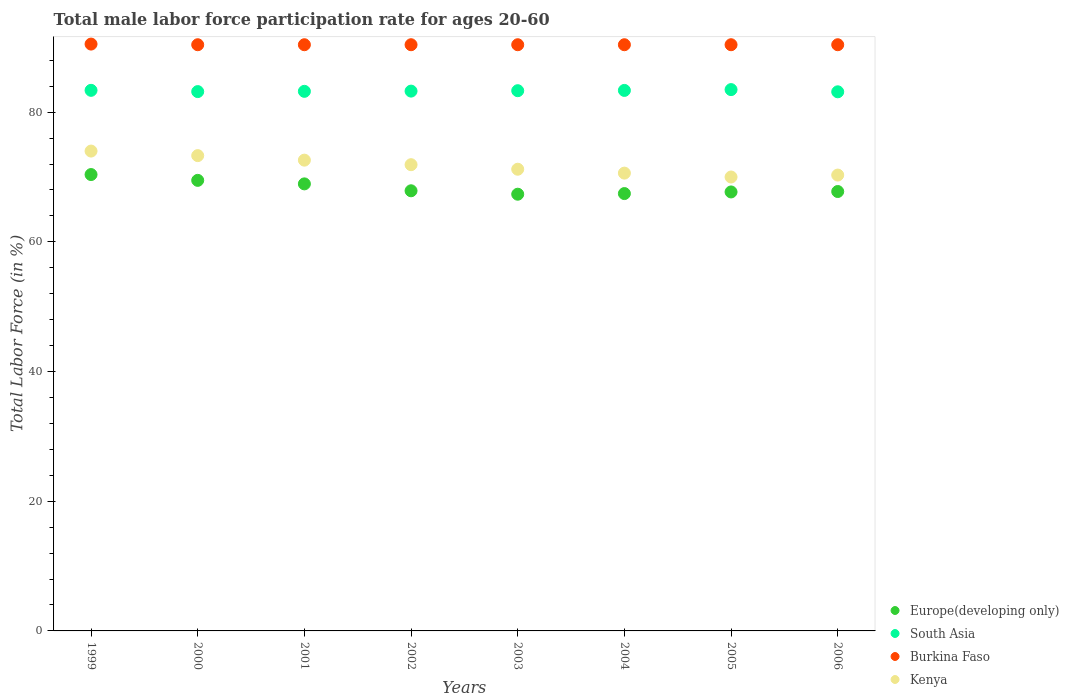What is the male labor force participation rate in Burkina Faso in 1999?
Keep it short and to the point. 90.5. Across all years, what is the maximum male labor force participation rate in South Asia?
Give a very brief answer. 83.48. Across all years, what is the minimum male labor force participation rate in South Asia?
Offer a very short reply. 83.14. In which year was the male labor force participation rate in Europe(developing only) maximum?
Make the answer very short. 1999. What is the total male labor force participation rate in Burkina Faso in the graph?
Provide a short and direct response. 723.3. What is the difference between the male labor force participation rate in Burkina Faso in 2000 and that in 2003?
Your answer should be compact. 0. What is the difference between the male labor force participation rate in Burkina Faso in 2000 and the male labor force participation rate in South Asia in 2005?
Give a very brief answer. 6.92. What is the average male labor force participation rate in South Asia per year?
Provide a succinct answer. 83.29. In the year 2002, what is the difference between the male labor force participation rate in Europe(developing only) and male labor force participation rate in Kenya?
Offer a terse response. -4.02. What is the difference between the highest and the second highest male labor force participation rate in Burkina Faso?
Your answer should be very brief. 0.1. What is the difference between the highest and the lowest male labor force participation rate in Kenya?
Make the answer very short. 4. In how many years, is the male labor force participation rate in Europe(developing only) greater than the average male labor force participation rate in Europe(developing only) taken over all years?
Give a very brief answer. 3. Is it the case that in every year, the sum of the male labor force participation rate in South Asia and male labor force participation rate in Kenya  is greater than the sum of male labor force participation rate in Europe(developing only) and male labor force participation rate in Burkina Faso?
Keep it short and to the point. Yes. Is the male labor force participation rate in Europe(developing only) strictly greater than the male labor force participation rate in Burkina Faso over the years?
Provide a short and direct response. No. How many dotlines are there?
Provide a short and direct response. 4. How many years are there in the graph?
Provide a short and direct response. 8. Are the values on the major ticks of Y-axis written in scientific E-notation?
Provide a succinct answer. No. Does the graph contain any zero values?
Keep it short and to the point. No. Does the graph contain grids?
Give a very brief answer. No. Where does the legend appear in the graph?
Offer a terse response. Bottom right. How many legend labels are there?
Provide a short and direct response. 4. What is the title of the graph?
Provide a short and direct response. Total male labor force participation rate for ages 20-60. Does "Low & middle income" appear as one of the legend labels in the graph?
Provide a succinct answer. No. What is the label or title of the Y-axis?
Your answer should be compact. Total Labor Force (in %). What is the Total Labor Force (in %) of Europe(developing only) in 1999?
Offer a terse response. 70.38. What is the Total Labor Force (in %) of South Asia in 1999?
Give a very brief answer. 83.37. What is the Total Labor Force (in %) of Burkina Faso in 1999?
Ensure brevity in your answer.  90.5. What is the Total Labor Force (in %) of Kenya in 1999?
Provide a short and direct response. 74. What is the Total Labor Force (in %) in Europe(developing only) in 2000?
Provide a succinct answer. 69.48. What is the Total Labor Force (in %) in South Asia in 2000?
Offer a very short reply. 83.17. What is the Total Labor Force (in %) in Burkina Faso in 2000?
Provide a short and direct response. 90.4. What is the Total Labor Force (in %) of Kenya in 2000?
Offer a terse response. 73.3. What is the Total Labor Force (in %) in Europe(developing only) in 2001?
Ensure brevity in your answer.  68.94. What is the Total Labor Force (in %) in South Asia in 2001?
Your response must be concise. 83.21. What is the Total Labor Force (in %) of Burkina Faso in 2001?
Make the answer very short. 90.4. What is the Total Labor Force (in %) in Kenya in 2001?
Your response must be concise. 72.6. What is the Total Labor Force (in %) in Europe(developing only) in 2002?
Your response must be concise. 67.88. What is the Total Labor Force (in %) in South Asia in 2002?
Offer a terse response. 83.25. What is the Total Labor Force (in %) in Burkina Faso in 2002?
Make the answer very short. 90.4. What is the Total Labor Force (in %) in Kenya in 2002?
Your response must be concise. 71.9. What is the Total Labor Force (in %) of Europe(developing only) in 2003?
Make the answer very short. 67.35. What is the Total Labor Force (in %) of South Asia in 2003?
Your response must be concise. 83.31. What is the Total Labor Force (in %) in Burkina Faso in 2003?
Your answer should be very brief. 90.4. What is the Total Labor Force (in %) in Kenya in 2003?
Your answer should be very brief. 71.2. What is the Total Labor Force (in %) in Europe(developing only) in 2004?
Your answer should be compact. 67.45. What is the Total Labor Force (in %) of South Asia in 2004?
Keep it short and to the point. 83.35. What is the Total Labor Force (in %) in Burkina Faso in 2004?
Provide a succinct answer. 90.4. What is the Total Labor Force (in %) of Kenya in 2004?
Offer a very short reply. 70.6. What is the Total Labor Force (in %) in Europe(developing only) in 2005?
Ensure brevity in your answer.  67.7. What is the Total Labor Force (in %) in South Asia in 2005?
Ensure brevity in your answer.  83.48. What is the Total Labor Force (in %) of Burkina Faso in 2005?
Offer a very short reply. 90.4. What is the Total Labor Force (in %) in Europe(developing only) in 2006?
Make the answer very short. 67.76. What is the Total Labor Force (in %) in South Asia in 2006?
Your answer should be compact. 83.14. What is the Total Labor Force (in %) in Burkina Faso in 2006?
Offer a terse response. 90.4. What is the Total Labor Force (in %) in Kenya in 2006?
Offer a very short reply. 70.3. Across all years, what is the maximum Total Labor Force (in %) in Europe(developing only)?
Provide a succinct answer. 70.38. Across all years, what is the maximum Total Labor Force (in %) of South Asia?
Provide a short and direct response. 83.48. Across all years, what is the maximum Total Labor Force (in %) of Burkina Faso?
Make the answer very short. 90.5. Across all years, what is the maximum Total Labor Force (in %) of Kenya?
Your answer should be very brief. 74. Across all years, what is the minimum Total Labor Force (in %) of Europe(developing only)?
Ensure brevity in your answer.  67.35. Across all years, what is the minimum Total Labor Force (in %) of South Asia?
Provide a succinct answer. 83.14. Across all years, what is the minimum Total Labor Force (in %) in Burkina Faso?
Give a very brief answer. 90.4. What is the total Total Labor Force (in %) of Europe(developing only) in the graph?
Your response must be concise. 546.93. What is the total Total Labor Force (in %) of South Asia in the graph?
Your answer should be very brief. 666.28. What is the total Total Labor Force (in %) of Burkina Faso in the graph?
Your answer should be very brief. 723.3. What is the total Total Labor Force (in %) of Kenya in the graph?
Your response must be concise. 573.9. What is the difference between the Total Labor Force (in %) of Europe(developing only) in 1999 and that in 2000?
Offer a very short reply. 0.9. What is the difference between the Total Labor Force (in %) in South Asia in 1999 and that in 2000?
Provide a succinct answer. 0.19. What is the difference between the Total Labor Force (in %) in Burkina Faso in 1999 and that in 2000?
Provide a succinct answer. 0.1. What is the difference between the Total Labor Force (in %) of Europe(developing only) in 1999 and that in 2001?
Give a very brief answer. 1.44. What is the difference between the Total Labor Force (in %) in South Asia in 1999 and that in 2001?
Ensure brevity in your answer.  0.16. What is the difference between the Total Labor Force (in %) in Burkina Faso in 1999 and that in 2001?
Keep it short and to the point. 0.1. What is the difference between the Total Labor Force (in %) of Europe(developing only) in 1999 and that in 2002?
Your response must be concise. 2.5. What is the difference between the Total Labor Force (in %) of South Asia in 1999 and that in 2002?
Your answer should be compact. 0.12. What is the difference between the Total Labor Force (in %) in Europe(developing only) in 1999 and that in 2003?
Keep it short and to the point. 3.03. What is the difference between the Total Labor Force (in %) in South Asia in 1999 and that in 2003?
Offer a very short reply. 0.06. What is the difference between the Total Labor Force (in %) of Kenya in 1999 and that in 2003?
Ensure brevity in your answer.  2.8. What is the difference between the Total Labor Force (in %) in Europe(developing only) in 1999 and that in 2004?
Provide a short and direct response. 2.93. What is the difference between the Total Labor Force (in %) in South Asia in 1999 and that in 2004?
Provide a short and direct response. 0.01. What is the difference between the Total Labor Force (in %) of Kenya in 1999 and that in 2004?
Provide a succinct answer. 3.4. What is the difference between the Total Labor Force (in %) of Europe(developing only) in 1999 and that in 2005?
Offer a terse response. 2.68. What is the difference between the Total Labor Force (in %) of South Asia in 1999 and that in 2005?
Offer a terse response. -0.11. What is the difference between the Total Labor Force (in %) of Burkina Faso in 1999 and that in 2005?
Offer a very short reply. 0.1. What is the difference between the Total Labor Force (in %) of Europe(developing only) in 1999 and that in 2006?
Offer a terse response. 2.62. What is the difference between the Total Labor Force (in %) in South Asia in 1999 and that in 2006?
Provide a succinct answer. 0.23. What is the difference between the Total Labor Force (in %) in Kenya in 1999 and that in 2006?
Your response must be concise. 3.7. What is the difference between the Total Labor Force (in %) in Europe(developing only) in 2000 and that in 2001?
Offer a terse response. 0.54. What is the difference between the Total Labor Force (in %) in South Asia in 2000 and that in 2001?
Offer a terse response. -0.04. What is the difference between the Total Labor Force (in %) in Burkina Faso in 2000 and that in 2001?
Give a very brief answer. 0. What is the difference between the Total Labor Force (in %) of Europe(developing only) in 2000 and that in 2002?
Your answer should be very brief. 1.61. What is the difference between the Total Labor Force (in %) in South Asia in 2000 and that in 2002?
Provide a succinct answer. -0.07. What is the difference between the Total Labor Force (in %) of Burkina Faso in 2000 and that in 2002?
Offer a terse response. 0. What is the difference between the Total Labor Force (in %) in Kenya in 2000 and that in 2002?
Give a very brief answer. 1.4. What is the difference between the Total Labor Force (in %) of Europe(developing only) in 2000 and that in 2003?
Keep it short and to the point. 2.14. What is the difference between the Total Labor Force (in %) in South Asia in 2000 and that in 2003?
Offer a very short reply. -0.14. What is the difference between the Total Labor Force (in %) of Europe(developing only) in 2000 and that in 2004?
Offer a terse response. 2.04. What is the difference between the Total Labor Force (in %) of South Asia in 2000 and that in 2004?
Give a very brief answer. -0.18. What is the difference between the Total Labor Force (in %) in Burkina Faso in 2000 and that in 2004?
Offer a very short reply. 0. What is the difference between the Total Labor Force (in %) in Kenya in 2000 and that in 2004?
Offer a terse response. 2.7. What is the difference between the Total Labor Force (in %) of Europe(developing only) in 2000 and that in 2005?
Keep it short and to the point. 1.79. What is the difference between the Total Labor Force (in %) in South Asia in 2000 and that in 2005?
Provide a short and direct response. -0.31. What is the difference between the Total Labor Force (in %) in Burkina Faso in 2000 and that in 2005?
Provide a short and direct response. 0. What is the difference between the Total Labor Force (in %) of Kenya in 2000 and that in 2005?
Make the answer very short. 3.3. What is the difference between the Total Labor Force (in %) of Europe(developing only) in 2000 and that in 2006?
Your response must be concise. 1.72. What is the difference between the Total Labor Force (in %) in South Asia in 2000 and that in 2006?
Your answer should be compact. 0.03. What is the difference between the Total Labor Force (in %) of Burkina Faso in 2000 and that in 2006?
Offer a very short reply. 0. What is the difference between the Total Labor Force (in %) in Kenya in 2000 and that in 2006?
Make the answer very short. 3. What is the difference between the Total Labor Force (in %) in Europe(developing only) in 2001 and that in 2002?
Keep it short and to the point. 1.07. What is the difference between the Total Labor Force (in %) of South Asia in 2001 and that in 2002?
Offer a terse response. -0.04. What is the difference between the Total Labor Force (in %) in Kenya in 2001 and that in 2002?
Provide a short and direct response. 0.7. What is the difference between the Total Labor Force (in %) in Europe(developing only) in 2001 and that in 2003?
Provide a short and direct response. 1.59. What is the difference between the Total Labor Force (in %) in South Asia in 2001 and that in 2003?
Your answer should be compact. -0.1. What is the difference between the Total Labor Force (in %) of Kenya in 2001 and that in 2003?
Your response must be concise. 1.4. What is the difference between the Total Labor Force (in %) in Europe(developing only) in 2001 and that in 2004?
Offer a terse response. 1.49. What is the difference between the Total Labor Force (in %) of South Asia in 2001 and that in 2004?
Offer a very short reply. -0.14. What is the difference between the Total Labor Force (in %) of Kenya in 2001 and that in 2004?
Provide a short and direct response. 2. What is the difference between the Total Labor Force (in %) of Europe(developing only) in 2001 and that in 2005?
Provide a succinct answer. 1.24. What is the difference between the Total Labor Force (in %) in South Asia in 2001 and that in 2005?
Offer a terse response. -0.27. What is the difference between the Total Labor Force (in %) of Europe(developing only) in 2001 and that in 2006?
Your answer should be very brief. 1.18. What is the difference between the Total Labor Force (in %) of South Asia in 2001 and that in 2006?
Keep it short and to the point. 0.07. What is the difference between the Total Labor Force (in %) of Burkina Faso in 2001 and that in 2006?
Offer a terse response. 0. What is the difference between the Total Labor Force (in %) of Kenya in 2001 and that in 2006?
Keep it short and to the point. 2.3. What is the difference between the Total Labor Force (in %) in Europe(developing only) in 2002 and that in 2003?
Provide a short and direct response. 0.53. What is the difference between the Total Labor Force (in %) of South Asia in 2002 and that in 2003?
Offer a terse response. -0.06. What is the difference between the Total Labor Force (in %) of Burkina Faso in 2002 and that in 2003?
Make the answer very short. 0. What is the difference between the Total Labor Force (in %) of Kenya in 2002 and that in 2003?
Provide a succinct answer. 0.7. What is the difference between the Total Labor Force (in %) in Europe(developing only) in 2002 and that in 2004?
Ensure brevity in your answer.  0.43. What is the difference between the Total Labor Force (in %) of South Asia in 2002 and that in 2004?
Offer a terse response. -0.11. What is the difference between the Total Labor Force (in %) of Europe(developing only) in 2002 and that in 2005?
Your answer should be compact. 0.18. What is the difference between the Total Labor Force (in %) in South Asia in 2002 and that in 2005?
Ensure brevity in your answer.  -0.23. What is the difference between the Total Labor Force (in %) of Burkina Faso in 2002 and that in 2005?
Your answer should be compact. 0. What is the difference between the Total Labor Force (in %) of Kenya in 2002 and that in 2005?
Provide a short and direct response. 1.9. What is the difference between the Total Labor Force (in %) of Europe(developing only) in 2002 and that in 2006?
Give a very brief answer. 0.11. What is the difference between the Total Labor Force (in %) in South Asia in 2002 and that in 2006?
Offer a terse response. 0.11. What is the difference between the Total Labor Force (in %) in Kenya in 2002 and that in 2006?
Give a very brief answer. 1.6. What is the difference between the Total Labor Force (in %) in Europe(developing only) in 2003 and that in 2004?
Offer a very short reply. -0.1. What is the difference between the Total Labor Force (in %) of South Asia in 2003 and that in 2004?
Make the answer very short. -0.04. What is the difference between the Total Labor Force (in %) of Burkina Faso in 2003 and that in 2004?
Your response must be concise. 0. What is the difference between the Total Labor Force (in %) in Kenya in 2003 and that in 2004?
Provide a short and direct response. 0.6. What is the difference between the Total Labor Force (in %) in Europe(developing only) in 2003 and that in 2005?
Your answer should be very brief. -0.35. What is the difference between the Total Labor Force (in %) in South Asia in 2003 and that in 2005?
Provide a succinct answer. -0.17. What is the difference between the Total Labor Force (in %) in Europe(developing only) in 2003 and that in 2006?
Keep it short and to the point. -0.42. What is the difference between the Total Labor Force (in %) in South Asia in 2003 and that in 2006?
Give a very brief answer. 0.17. What is the difference between the Total Labor Force (in %) of Kenya in 2003 and that in 2006?
Keep it short and to the point. 0.9. What is the difference between the Total Labor Force (in %) of Europe(developing only) in 2004 and that in 2005?
Provide a succinct answer. -0.25. What is the difference between the Total Labor Force (in %) in South Asia in 2004 and that in 2005?
Make the answer very short. -0.12. What is the difference between the Total Labor Force (in %) in Burkina Faso in 2004 and that in 2005?
Offer a terse response. 0. What is the difference between the Total Labor Force (in %) in Kenya in 2004 and that in 2005?
Make the answer very short. 0.6. What is the difference between the Total Labor Force (in %) of Europe(developing only) in 2004 and that in 2006?
Your response must be concise. -0.32. What is the difference between the Total Labor Force (in %) of South Asia in 2004 and that in 2006?
Ensure brevity in your answer.  0.21. What is the difference between the Total Labor Force (in %) of Kenya in 2004 and that in 2006?
Offer a terse response. 0.3. What is the difference between the Total Labor Force (in %) of Europe(developing only) in 2005 and that in 2006?
Provide a short and direct response. -0.07. What is the difference between the Total Labor Force (in %) of South Asia in 2005 and that in 2006?
Give a very brief answer. 0.34. What is the difference between the Total Labor Force (in %) in Kenya in 2005 and that in 2006?
Make the answer very short. -0.3. What is the difference between the Total Labor Force (in %) of Europe(developing only) in 1999 and the Total Labor Force (in %) of South Asia in 2000?
Your response must be concise. -12.79. What is the difference between the Total Labor Force (in %) in Europe(developing only) in 1999 and the Total Labor Force (in %) in Burkina Faso in 2000?
Provide a succinct answer. -20.02. What is the difference between the Total Labor Force (in %) in Europe(developing only) in 1999 and the Total Labor Force (in %) in Kenya in 2000?
Your answer should be compact. -2.92. What is the difference between the Total Labor Force (in %) of South Asia in 1999 and the Total Labor Force (in %) of Burkina Faso in 2000?
Offer a very short reply. -7.03. What is the difference between the Total Labor Force (in %) of South Asia in 1999 and the Total Labor Force (in %) of Kenya in 2000?
Your answer should be very brief. 10.07. What is the difference between the Total Labor Force (in %) of Burkina Faso in 1999 and the Total Labor Force (in %) of Kenya in 2000?
Keep it short and to the point. 17.2. What is the difference between the Total Labor Force (in %) of Europe(developing only) in 1999 and the Total Labor Force (in %) of South Asia in 2001?
Keep it short and to the point. -12.83. What is the difference between the Total Labor Force (in %) in Europe(developing only) in 1999 and the Total Labor Force (in %) in Burkina Faso in 2001?
Offer a very short reply. -20.02. What is the difference between the Total Labor Force (in %) in Europe(developing only) in 1999 and the Total Labor Force (in %) in Kenya in 2001?
Offer a terse response. -2.22. What is the difference between the Total Labor Force (in %) in South Asia in 1999 and the Total Labor Force (in %) in Burkina Faso in 2001?
Provide a short and direct response. -7.03. What is the difference between the Total Labor Force (in %) in South Asia in 1999 and the Total Labor Force (in %) in Kenya in 2001?
Provide a short and direct response. 10.77. What is the difference between the Total Labor Force (in %) of Burkina Faso in 1999 and the Total Labor Force (in %) of Kenya in 2001?
Your answer should be very brief. 17.9. What is the difference between the Total Labor Force (in %) in Europe(developing only) in 1999 and the Total Labor Force (in %) in South Asia in 2002?
Ensure brevity in your answer.  -12.87. What is the difference between the Total Labor Force (in %) of Europe(developing only) in 1999 and the Total Labor Force (in %) of Burkina Faso in 2002?
Offer a terse response. -20.02. What is the difference between the Total Labor Force (in %) of Europe(developing only) in 1999 and the Total Labor Force (in %) of Kenya in 2002?
Make the answer very short. -1.52. What is the difference between the Total Labor Force (in %) of South Asia in 1999 and the Total Labor Force (in %) of Burkina Faso in 2002?
Provide a short and direct response. -7.03. What is the difference between the Total Labor Force (in %) in South Asia in 1999 and the Total Labor Force (in %) in Kenya in 2002?
Your response must be concise. 11.47. What is the difference between the Total Labor Force (in %) in Burkina Faso in 1999 and the Total Labor Force (in %) in Kenya in 2002?
Your answer should be compact. 18.6. What is the difference between the Total Labor Force (in %) in Europe(developing only) in 1999 and the Total Labor Force (in %) in South Asia in 2003?
Keep it short and to the point. -12.93. What is the difference between the Total Labor Force (in %) of Europe(developing only) in 1999 and the Total Labor Force (in %) of Burkina Faso in 2003?
Your response must be concise. -20.02. What is the difference between the Total Labor Force (in %) in Europe(developing only) in 1999 and the Total Labor Force (in %) in Kenya in 2003?
Make the answer very short. -0.82. What is the difference between the Total Labor Force (in %) of South Asia in 1999 and the Total Labor Force (in %) of Burkina Faso in 2003?
Ensure brevity in your answer.  -7.03. What is the difference between the Total Labor Force (in %) in South Asia in 1999 and the Total Labor Force (in %) in Kenya in 2003?
Make the answer very short. 12.17. What is the difference between the Total Labor Force (in %) in Burkina Faso in 1999 and the Total Labor Force (in %) in Kenya in 2003?
Your answer should be very brief. 19.3. What is the difference between the Total Labor Force (in %) of Europe(developing only) in 1999 and the Total Labor Force (in %) of South Asia in 2004?
Ensure brevity in your answer.  -12.98. What is the difference between the Total Labor Force (in %) in Europe(developing only) in 1999 and the Total Labor Force (in %) in Burkina Faso in 2004?
Give a very brief answer. -20.02. What is the difference between the Total Labor Force (in %) of Europe(developing only) in 1999 and the Total Labor Force (in %) of Kenya in 2004?
Provide a short and direct response. -0.22. What is the difference between the Total Labor Force (in %) of South Asia in 1999 and the Total Labor Force (in %) of Burkina Faso in 2004?
Provide a short and direct response. -7.03. What is the difference between the Total Labor Force (in %) of South Asia in 1999 and the Total Labor Force (in %) of Kenya in 2004?
Ensure brevity in your answer.  12.77. What is the difference between the Total Labor Force (in %) of Europe(developing only) in 1999 and the Total Labor Force (in %) of South Asia in 2005?
Keep it short and to the point. -13.1. What is the difference between the Total Labor Force (in %) of Europe(developing only) in 1999 and the Total Labor Force (in %) of Burkina Faso in 2005?
Give a very brief answer. -20.02. What is the difference between the Total Labor Force (in %) of Europe(developing only) in 1999 and the Total Labor Force (in %) of Kenya in 2005?
Keep it short and to the point. 0.38. What is the difference between the Total Labor Force (in %) in South Asia in 1999 and the Total Labor Force (in %) in Burkina Faso in 2005?
Make the answer very short. -7.03. What is the difference between the Total Labor Force (in %) of South Asia in 1999 and the Total Labor Force (in %) of Kenya in 2005?
Keep it short and to the point. 13.37. What is the difference between the Total Labor Force (in %) in Burkina Faso in 1999 and the Total Labor Force (in %) in Kenya in 2005?
Give a very brief answer. 20.5. What is the difference between the Total Labor Force (in %) in Europe(developing only) in 1999 and the Total Labor Force (in %) in South Asia in 2006?
Your answer should be compact. -12.76. What is the difference between the Total Labor Force (in %) in Europe(developing only) in 1999 and the Total Labor Force (in %) in Burkina Faso in 2006?
Your answer should be very brief. -20.02. What is the difference between the Total Labor Force (in %) in Europe(developing only) in 1999 and the Total Labor Force (in %) in Kenya in 2006?
Give a very brief answer. 0.08. What is the difference between the Total Labor Force (in %) in South Asia in 1999 and the Total Labor Force (in %) in Burkina Faso in 2006?
Your answer should be compact. -7.03. What is the difference between the Total Labor Force (in %) in South Asia in 1999 and the Total Labor Force (in %) in Kenya in 2006?
Keep it short and to the point. 13.07. What is the difference between the Total Labor Force (in %) in Burkina Faso in 1999 and the Total Labor Force (in %) in Kenya in 2006?
Make the answer very short. 20.2. What is the difference between the Total Labor Force (in %) of Europe(developing only) in 2000 and the Total Labor Force (in %) of South Asia in 2001?
Offer a terse response. -13.73. What is the difference between the Total Labor Force (in %) in Europe(developing only) in 2000 and the Total Labor Force (in %) in Burkina Faso in 2001?
Provide a succinct answer. -20.92. What is the difference between the Total Labor Force (in %) of Europe(developing only) in 2000 and the Total Labor Force (in %) of Kenya in 2001?
Offer a terse response. -3.12. What is the difference between the Total Labor Force (in %) in South Asia in 2000 and the Total Labor Force (in %) in Burkina Faso in 2001?
Make the answer very short. -7.23. What is the difference between the Total Labor Force (in %) of South Asia in 2000 and the Total Labor Force (in %) of Kenya in 2001?
Ensure brevity in your answer.  10.57. What is the difference between the Total Labor Force (in %) in Burkina Faso in 2000 and the Total Labor Force (in %) in Kenya in 2001?
Ensure brevity in your answer.  17.8. What is the difference between the Total Labor Force (in %) of Europe(developing only) in 2000 and the Total Labor Force (in %) of South Asia in 2002?
Your answer should be very brief. -13.76. What is the difference between the Total Labor Force (in %) of Europe(developing only) in 2000 and the Total Labor Force (in %) of Burkina Faso in 2002?
Offer a terse response. -20.92. What is the difference between the Total Labor Force (in %) in Europe(developing only) in 2000 and the Total Labor Force (in %) in Kenya in 2002?
Your response must be concise. -2.42. What is the difference between the Total Labor Force (in %) of South Asia in 2000 and the Total Labor Force (in %) of Burkina Faso in 2002?
Provide a short and direct response. -7.23. What is the difference between the Total Labor Force (in %) in South Asia in 2000 and the Total Labor Force (in %) in Kenya in 2002?
Your response must be concise. 11.27. What is the difference between the Total Labor Force (in %) of Europe(developing only) in 2000 and the Total Labor Force (in %) of South Asia in 2003?
Offer a terse response. -13.83. What is the difference between the Total Labor Force (in %) in Europe(developing only) in 2000 and the Total Labor Force (in %) in Burkina Faso in 2003?
Your response must be concise. -20.92. What is the difference between the Total Labor Force (in %) of Europe(developing only) in 2000 and the Total Labor Force (in %) of Kenya in 2003?
Ensure brevity in your answer.  -1.72. What is the difference between the Total Labor Force (in %) in South Asia in 2000 and the Total Labor Force (in %) in Burkina Faso in 2003?
Ensure brevity in your answer.  -7.23. What is the difference between the Total Labor Force (in %) of South Asia in 2000 and the Total Labor Force (in %) of Kenya in 2003?
Offer a very short reply. 11.97. What is the difference between the Total Labor Force (in %) in Europe(developing only) in 2000 and the Total Labor Force (in %) in South Asia in 2004?
Keep it short and to the point. -13.87. What is the difference between the Total Labor Force (in %) of Europe(developing only) in 2000 and the Total Labor Force (in %) of Burkina Faso in 2004?
Keep it short and to the point. -20.92. What is the difference between the Total Labor Force (in %) of Europe(developing only) in 2000 and the Total Labor Force (in %) of Kenya in 2004?
Provide a short and direct response. -1.12. What is the difference between the Total Labor Force (in %) of South Asia in 2000 and the Total Labor Force (in %) of Burkina Faso in 2004?
Offer a terse response. -7.23. What is the difference between the Total Labor Force (in %) of South Asia in 2000 and the Total Labor Force (in %) of Kenya in 2004?
Your response must be concise. 12.57. What is the difference between the Total Labor Force (in %) of Burkina Faso in 2000 and the Total Labor Force (in %) of Kenya in 2004?
Your response must be concise. 19.8. What is the difference between the Total Labor Force (in %) in Europe(developing only) in 2000 and the Total Labor Force (in %) in South Asia in 2005?
Give a very brief answer. -14. What is the difference between the Total Labor Force (in %) in Europe(developing only) in 2000 and the Total Labor Force (in %) in Burkina Faso in 2005?
Ensure brevity in your answer.  -20.92. What is the difference between the Total Labor Force (in %) of Europe(developing only) in 2000 and the Total Labor Force (in %) of Kenya in 2005?
Offer a very short reply. -0.52. What is the difference between the Total Labor Force (in %) of South Asia in 2000 and the Total Labor Force (in %) of Burkina Faso in 2005?
Offer a terse response. -7.23. What is the difference between the Total Labor Force (in %) in South Asia in 2000 and the Total Labor Force (in %) in Kenya in 2005?
Make the answer very short. 13.17. What is the difference between the Total Labor Force (in %) in Burkina Faso in 2000 and the Total Labor Force (in %) in Kenya in 2005?
Make the answer very short. 20.4. What is the difference between the Total Labor Force (in %) of Europe(developing only) in 2000 and the Total Labor Force (in %) of South Asia in 2006?
Provide a short and direct response. -13.66. What is the difference between the Total Labor Force (in %) in Europe(developing only) in 2000 and the Total Labor Force (in %) in Burkina Faso in 2006?
Offer a very short reply. -20.92. What is the difference between the Total Labor Force (in %) of Europe(developing only) in 2000 and the Total Labor Force (in %) of Kenya in 2006?
Provide a short and direct response. -0.82. What is the difference between the Total Labor Force (in %) of South Asia in 2000 and the Total Labor Force (in %) of Burkina Faso in 2006?
Your answer should be very brief. -7.23. What is the difference between the Total Labor Force (in %) in South Asia in 2000 and the Total Labor Force (in %) in Kenya in 2006?
Offer a very short reply. 12.87. What is the difference between the Total Labor Force (in %) of Burkina Faso in 2000 and the Total Labor Force (in %) of Kenya in 2006?
Your response must be concise. 20.1. What is the difference between the Total Labor Force (in %) in Europe(developing only) in 2001 and the Total Labor Force (in %) in South Asia in 2002?
Offer a very short reply. -14.31. What is the difference between the Total Labor Force (in %) in Europe(developing only) in 2001 and the Total Labor Force (in %) in Burkina Faso in 2002?
Your answer should be compact. -21.46. What is the difference between the Total Labor Force (in %) in Europe(developing only) in 2001 and the Total Labor Force (in %) in Kenya in 2002?
Your answer should be compact. -2.96. What is the difference between the Total Labor Force (in %) of South Asia in 2001 and the Total Labor Force (in %) of Burkina Faso in 2002?
Offer a terse response. -7.19. What is the difference between the Total Labor Force (in %) in South Asia in 2001 and the Total Labor Force (in %) in Kenya in 2002?
Give a very brief answer. 11.31. What is the difference between the Total Labor Force (in %) in Burkina Faso in 2001 and the Total Labor Force (in %) in Kenya in 2002?
Keep it short and to the point. 18.5. What is the difference between the Total Labor Force (in %) of Europe(developing only) in 2001 and the Total Labor Force (in %) of South Asia in 2003?
Offer a very short reply. -14.37. What is the difference between the Total Labor Force (in %) in Europe(developing only) in 2001 and the Total Labor Force (in %) in Burkina Faso in 2003?
Give a very brief answer. -21.46. What is the difference between the Total Labor Force (in %) of Europe(developing only) in 2001 and the Total Labor Force (in %) of Kenya in 2003?
Provide a succinct answer. -2.26. What is the difference between the Total Labor Force (in %) of South Asia in 2001 and the Total Labor Force (in %) of Burkina Faso in 2003?
Make the answer very short. -7.19. What is the difference between the Total Labor Force (in %) in South Asia in 2001 and the Total Labor Force (in %) in Kenya in 2003?
Give a very brief answer. 12.01. What is the difference between the Total Labor Force (in %) in Burkina Faso in 2001 and the Total Labor Force (in %) in Kenya in 2003?
Ensure brevity in your answer.  19.2. What is the difference between the Total Labor Force (in %) of Europe(developing only) in 2001 and the Total Labor Force (in %) of South Asia in 2004?
Your answer should be very brief. -14.41. What is the difference between the Total Labor Force (in %) in Europe(developing only) in 2001 and the Total Labor Force (in %) in Burkina Faso in 2004?
Your response must be concise. -21.46. What is the difference between the Total Labor Force (in %) of Europe(developing only) in 2001 and the Total Labor Force (in %) of Kenya in 2004?
Your response must be concise. -1.66. What is the difference between the Total Labor Force (in %) in South Asia in 2001 and the Total Labor Force (in %) in Burkina Faso in 2004?
Keep it short and to the point. -7.19. What is the difference between the Total Labor Force (in %) in South Asia in 2001 and the Total Labor Force (in %) in Kenya in 2004?
Offer a very short reply. 12.61. What is the difference between the Total Labor Force (in %) of Burkina Faso in 2001 and the Total Labor Force (in %) of Kenya in 2004?
Offer a very short reply. 19.8. What is the difference between the Total Labor Force (in %) of Europe(developing only) in 2001 and the Total Labor Force (in %) of South Asia in 2005?
Provide a short and direct response. -14.54. What is the difference between the Total Labor Force (in %) in Europe(developing only) in 2001 and the Total Labor Force (in %) in Burkina Faso in 2005?
Your answer should be very brief. -21.46. What is the difference between the Total Labor Force (in %) in Europe(developing only) in 2001 and the Total Labor Force (in %) in Kenya in 2005?
Give a very brief answer. -1.06. What is the difference between the Total Labor Force (in %) in South Asia in 2001 and the Total Labor Force (in %) in Burkina Faso in 2005?
Offer a very short reply. -7.19. What is the difference between the Total Labor Force (in %) in South Asia in 2001 and the Total Labor Force (in %) in Kenya in 2005?
Make the answer very short. 13.21. What is the difference between the Total Labor Force (in %) in Burkina Faso in 2001 and the Total Labor Force (in %) in Kenya in 2005?
Offer a very short reply. 20.4. What is the difference between the Total Labor Force (in %) in Europe(developing only) in 2001 and the Total Labor Force (in %) in South Asia in 2006?
Your response must be concise. -14.2. What is the difference between the Total Labor Force (in %) in Europe(developing only) in 2001 and the Total Labor Force (in %) in Burkina Faso in 2006?
Keep it short and to the point. -21.46. What is the difference between the Total Labor Force (in %) in Europe(developing only) in 2001 and the Total Labor Force (in %) in Kenya in 2006?
Provide a succinct answer. -1.36. What is the difference between the Total Labor Force (in %) in South Asia in 2001 and the Total Labor Force (in %) in Burkina Faso in 2006?
Ensure brevity in your answer.  -7.19. What is the difference between the Total Labor Force (in %) in South Asia in 2001 and the Total Labor Force (in %) in Kenya in 2006?
Offer a very short reply. 12.91. What is the difference between the Total Labor Force (in %) of Burkina Faso in 2001 and the Total Labor Force (in %) of Kenya in 2006?
Make the answer very short. 20.1. What is the difference between the Total Labor Force (in %) in Europe(developing only) in 2002 and the Total Labor Force (in %) in South Asia in 2003?
Your answer should be compact. -15.44. What is the difference between the Total Labor Force (in %) in Europe(developing only) in 2002 and the Total Labor Force (in %) in Burkina Faso in 2003?
Give a very brief answer. -22.52. What is the difference between the Total Labor Force (in %) in Europe(developing only) in 2002 and the Total Labor Force (in %) in Kenya in 2003?
Provide a succinct answer. -3.33. What is the difference between the Total Labor Force (in %) in South Asia in 2002 and the Total Labor Force (in %) in Burkina Faso in 2003?
Make the answer very short. -7.15. What is the difference between the Total Labor Force (in %) of South Asia in 2002 and the Total Labor Force (in %) of Kenya in 2003?
Give a very brief answer. 12.05. What is the difference between the Total Labor Force (in %) of Europe(developing only) in 2002 and the Total Labor Force (in %) of South Asia in 2004?
Offer a very short reply. -15.48. What is the difference between the Total Labor Force (in %) in Europe(developing only) in 2002 and the Total Labor Force (in %) in Burkina Faso in 2004?
Your answer should be very brief. -22.52. What is the difference between the Total Labor Force (in %) of Europe(developing only) in 2002 and the Total Labor Force (in %) of Kenya in 2004?
Your response must be concise. -2.73. What is the difference between the Total Labor Force (in %) of South Asia in 2002 and the Total Labor Force (in %) of Burkina Faso in 2004?
Your answer should be very brief. -7.15. What is the difference between the Total Labor Force (in %) of South Asia in 2002 and the Total Labor Force (in %) of Kenya in 2004?
Provide a succinct answer. 12.65. What is the difference between the Total Labor Force (in %) of Burkina Faso in 2002 and the Total Labor Force (in %) of Kenya in 2004?
Provide a short and direct response. 19.8. What is the difference between the Total Labor Force (in %) in Europe(developing only) in 2002 and the Total Labor Force (in %) in South Asia in 2005?
Offer a very short reply. -15.6. What is the difference between the Total Labor Force (in %) of Europe(developing only) in 2002 and the Total Labor Force (in %) of Burkina Faso in 2005?
Keep it short and to the point. -22.52. What is the difference between the Total Labor Force (in %) in Europe(developing only) in 2002 and the Total Labor Force (in %) in Kenya in 2005?
Ensure brevity in your answer.  -2.12. What is the difference between the Total Labor Force (in %) in South Asia in 2002 and the Total Labor Force (in %) in Burkina Faso in 2005?
Your response must be concise. -7.15. What is the difference between the Total Labor Force (in %) in South Asia in 2002 and the Total Labor Force (in %) in Kenya in 2005?
Your response must be concise. 13.25. What is the difference between the Total Labor Force (in %) in Burkina Faso in 2002 and the Total Labor Force (in %) in Kenya in 2005?
Give a very brief answer. 20.4. What is the difference between the Total Labor Force (in %) in Europe(developing only) in 2002 and the Total Labor Force (in %) in South Asia in 2006?
Ensure brevity in your answer.  -15.27. What is the difference between the Total Labor Force (in %) in Europe(developing only) in 2002 and the Total Labor Force (in %) in Burkina Faso in 2006?
Provide a short and direct response. -22.52. What is the difference between the Total Labor Force (in %) of Europe(developing only) in 2002 and the Total Labor Force (in %) of Kenya in 2006?
Keep it short and to the point. -2.42. What is the difference between the Total Labor Force (in %) in South Asia in 2002 and the Total Labor Force (in %) in Burkina Faso in 2006?
Provide a succinct answer. -7.15. What is the difference between the Total Labor Force (in %) of South Asia in 2002 and the Total Labor Force (in %) of Kenya in 2006?
Make the answer very short. 12.95. What is the difference between the Total Labor Force (in %) of Burkina Faso in 2002 and the Total Labor Force (in %) of Kenya in 2006?
Ensure brevity in your answer.  20.1. What is the difference between the Total Labor Force (in %) in Europe(developing only) in 2003 and the Total Labor Force (in %) in South Asia in 2004?
Give a very brief answer. -16.01. What is the difference between the Total Labor Force (in %) of Europe(developing only) in 2003 and the Total Labor Force (in %) of Burkina Faso in 2004?
Offer a very short reply. -23.05. What is the difference between the Total Labor Force (in %) in Europe(developing only) in 2003 and the Total Labor Force (in %) in Kenya in 2004?
Your answer should be very brief. -3.25. What is the difference between the Total Labor Force (in %) of South Asia in 2003 and the Total Labor Force (in %) of Burkina Faso in 2004?
Provide a short and direct response. -7.09. What is the difference between the Total Labor Force (in %) in South Asia in 2003 and the Total Labor Force (in %) in Kenya in 2004?
Provide a succinct answer. 12.71. What is the difference between the Total Labor Force (in %) of Burkina Faso in 2003 and the Total Labor Force (in %) of Kenya in 2004?
Your response must be concise. 19.8. What is the difference between the Total Labor Force (in %) of Europe(developing only) in 2003 and the Total Labor Force (in %) of South Asia in 2005?
Your answer should be compact. -16.13. What is the difference between the Total Labor Force (in %) in Europe(developing only) in 2003 and the Total Labor Force (in %) in Burkina Faso in 2005?
Your answer should be very brief. -23.05. What is the difference between the Total Labor Force (in %) of Europe(developing only) in 2003 and the Total Labor Force (in %) of Kenya in 2005?
Keep it short and to the point. -2.65. What is the difference between the Total Labor Force (in %) of South Asia in 2003 and the Total Labor Force (in %) of Burkina Faso in 2005?
Give a very brief answer. -7.09. What is the difference between the Total Labor Force (in %) in South Asia in 2003 and the Total Labor Force (in %) in Kenya in 2005?
Your answer should be very brief. 13.31. What is the difference between the Total Labor Force (in %) in Burkina Faso in 2003 and the Total Labor Force (in %) in Kenya in 2005?
Provide a short and direct response. 20.4. What is the difference between the Total Labor Force (in %) in Europe(developing only) in 2003 and the Total Labor Force (in %) in South Asia in 2006?
Your answer should be compact. -15.79. What is the difference between the Total Labor Force (in %) in Europe(developing only) in 2003 and the Total Labor Force (in %) in Burkina Faso in 2006?
Make the answer very short. -23.05. What is the difference between the Total Labor Force (in %) of Europe(developing only) in 2003 and the Total Labor Force (in %) of Kenya in 2006?
Ensure brevity in your answer.  -2.95. What is the difference between the Total Labor Force (in %) of South Asia in 2003 and the Total Labor Force (in %) of Burkina Faso in 2006?
Make the answer very short. -7.09. What is the difference between the Total Labor Force (in %) in South Asia in 2003 and the Total Labor Force (in %) in Kenya in 2006?
Offer a very short reply. 13.01. What is the difference between the Total Labor Force (in %) in Burkina Faso in 2003 and the Total Labor Force (in %) in Kenya in 2006?
Keep it short and to the point. 20.1. What is the difference between the Total Labor Force (in %) of Europe(developing only) in 2004 and the Total Labor Force (in %) of South Asia in 2005?
Offer a terse response. -16.03. What is the difference between the Total Labor Force (in %) in Europe(developing only) in 2004 and the Total Labor Force (in %) in Burkina Faso in 2005?
Make the answer very short. -22.95. What is the difference between the Total Labor Force (in %) of Europe(developing only) in 2004 and the Total Labor Force (in %) of Kenya in 2005?
Provide a succinct answer. -2.55. What is the difference between the Total Labor Force (in %) of South Asia in 2004 and the Total Labor Force (in %) of Burkina Faso in 2005?
Provide a succinct answer. -7.05. What is the difference between the Total Labor Force (in %) in South Asia in 2004 and the Total Labor Force (in %) in Kenya in 2005?
Provide a succinct answer. 13.35. What is the difference between the Total Labor Force (in %) of Burkina Faso in 2004 and the Total Labor Force (in %) of Kenya in 2005?
Your answer should be very brief. 20.4. What is the difference between the Total Labor Force (in %) in Europe(developing only) in 2004 and the Total Labor Force (in %) in South Asia in 2006?
Your answer should be compact. -15.69. What is the difference between the Total Labor Force (in %) of Europe(developing only) in 2004 and the Total Labor Force (in %) of Burkina Faso in 2006?
Keep it short and to the point. -22.95. What is the difference between the Total Labor Force (in %) of Europe(developing only) in 2004 and the Total Labor Force (in %) of Kenya in 2006?
Provide a short and direct response. -2.85. What is the difference between the Total Labor Force (in %) in South Asia in 2004 and the Total Labor Force (in %) in Burkina Faso in 2006?
Offer a very short reply. -7.05. What is the difference between the Total Labor Force (in %) in South Asia in 2004 and the Total Labor Force (in %) in Kenya in 2006?
Keep it short and to the point. 13.05. What is the difference between the Total Labor Force (in %) in Burkina Faso in 2004 and the Total Labor Force (in %) in Kenya in 2006?
Provide a short and direct response. 20.1. What is the difference between the Total Labor Force (in %) of Europe(developing only) in 2005 and the Total Labor Force (in %) of South Asia in 2006?
Make the answer very short. -15.44. What is the difference between the Total Labor Force (in %) of Europe(developing only) in 2005 and the Total Labor Force (in %) of Burkina Faso in 2006?
Provide a succinct answer. -22.7. What is the difference between the Total Labor Force (in %) in Europe(developing only) in 2005 and the Total Labor Force (in %) in Kenya in 2006?
Ensure brevity in your answer.  -2.6. What is the difference between the Total Labor Force (in %) in South Asia in 2005 and the Total Labor Force (in %) in Burkina Faso in 2006?
Offer a terse response. -6.92. What is the difference between the Total Labor Force (in %) of South Asia in 2005 and the Total Labor Force (in %) of Kenya in 2006?
Give a very brief answer. 13.18. What is the difference between the Total Labor Force (in %) in Burkina Faso in 2005 and the Total Labor Force (in %) in Kenya in 2006?
Offer a terse response. 20.1. What is the average Total Labor Force (in %) of Europe(developing only) per year?
Give a very brief answer. 68.37. What is the average Total Labor Force (in %) of South Asia per year?
Provide a short and direct response. 83.29. What is the average Total Labor Force (in %) in Burkina Faso per year?
Make the answer very short. 90.41. What is the average Total Labor Force (in %) in Kenya per year?
Provide a succinct answer. 71.74. In the year 1999, what is the difference between the Total Labor Force (in %) of Europe(developing only) and Total Labor Force (in %) of South Asia?
Make the answer very short. -12.99. In the year 1999, what is the difference between the Total Labor Force (in %) in Europe(developing only) and Total Labor Force (in %) in Burkina Faso?
Your answer should be very brief. -20.12. In the year 1999, what is the difference between the Total Labor Force (in %) in Europe(developing only) and Total Labor Force (in %) in Kenya?
Keep it short and to the point. -3.62. In the year 1999, what is the difference between the Total Labor Force (in %) in South Asia and Total Labor Force (in %) in Burkina Faso?
Offer a very short reply. -7.13. In the year 1999, what is the difference between the Total Labor Force (in %) in South Asia and Total Labor Force (in %) in Kenya?
Make the answer very short. 9.37. In the year 2000, what is the difference between the Total Labor Force (in %) in Europe(developing only) and Total Labor Force (in %) in South Asia?
Ensure brevity in your answer.  -13.69. In the year 2000, what is the difference between the Total Labor Force (in %) of Europe(developing only) and Total Labor Force (in %) of Burkina Faso?
Offer a very short reply. -20.92. In the year 2000, what is the difference between the Total Labor Force (in %) of Europe(developing only) and Total Labor Force (in %) of Kenya?
Your response must be concise. -3.82. In the year 2000, what is the difference between the Total Labor Force (in %) of South Asia and Total Labor Force (in %) of Burkina Faso?
Your answer should be very brief. -7.23. In the year 2000, what is the difference between the Total Labor Force (in %) of South Asia and Total Labor Force (in %) of Kenya?
Provide a succinct answer. 9.87. In the year 2001, what is the difference between the Total Labor Force (in %) of Europe(developing only) and Total Labor Force (in %) of South Asia?
Offer a very short reply. -14.27. In the year 2001, what is the difference between the Total Labor Force (in %) in Europe(developing only) and Total Labor Force (in %) in Burkina Faso?
Your response must be concise. -21.46. In the year 2001, what is the difference between the Total Labor Force (in %) in Europe(developing only) and Total Labor Force (in %) in Kenya?
Your answer should be very brief. -3.66. In the year 2001, what is the difference between the Total Labor Force (in %) of South Asia and Total Labor Force (in %) of Burkina Faso?
Provide a short and direct response. -7.19. In the year 2001, what is the difference between the Total Labor Force (in %) of South Asia and Total Labor Force (in %) of Kenya?
Offer a very short reply. 10.61. In the year 2001, what is the difference between the Total Labor Force (in %) of Burkina Faso and Total Labor Force (in %) of Kenya?
Ensure brevity in your answer.  17.8. In the year 2002, what is the difference between the Total Labor Force (in %) of Europe(developing only) and Total Labor Force (in %) of South Asia?
Your answer should be very brief. -15.37. In the year 2002, what is the difference between the Total Labor Force (in %) of Europe(developing only) and Total Labor Force (in %) of Burkina Faso?
Give a very brief answer. -22.52. In the year 2002, what is the difference between the Total Labor Force (in %) in Europe(developing only) and Total Labor Force (in %) in Kenya?
Give a very brief answer. -4.03. In the year 2002, what is the difference between the Total Labor Force (in %) of South Asia and Total Labor Force (in %) of Burkina Faso?
Provide a short and direct response. -7.15. In the year 2002, what is the difference between the Total Labor Force (in %) in South Asia and Total Labor Force (in %) in Kenya?
Your response must be concise. 11.35. In the year 2002, what is the difference between the Total Labor Force (in %) in Burkina Faso and Total Labor Force (in %) in Kenya?
Provide a short and direct response. 18.5. In the year 2003, what is the difference between the Total Labor Force (in %) of Europe(developing only) and Total Labor Force (in %) of South Asia?
Keep it short and to the point. -15.96. In the year 2003, what is the difference between the Total Labor Force (in %) in Europe(developing only) and Total Labor Force (in %) in Burkina Faso?
Make the answer very short. -23.05. In the year 2003, what is the difference between the Total Labor Force (in %) in Europe(developing only) and Total Labor Force (in %) in Kenya?
Provide a succinct answer. -3.85. In the year 2003, what is the difference between the Total Labor Force (in %) of South Asia and Total Labor Force (in %) of Burkina Faso?
Ensure brevity in your answer.  -7.09. In the year 2003, what is the difference between the Total Labor Force (in %) of South Asia and Total Labor Force (in %) of Kenya?
Your answer should be compact. 12.11. In the year 2004, what is the difference between the Total Labor Force (in %) in Europe(developing only) and Total Labor Force (in %) in South Asia?
Your response must be concise. -15.91. In the year 2004, what is the difference between the Total Labor Force (in %) of Europe(developing only) and Total Labor Force (in %) of Burkina Faso?
Your answer should be very brief. -22.95. In the year 2004, what is the difference between the Total Labor Force (in %) in Europe(developing only) and Total Labor Force (in %) in Kenya?
Make the answer very short. -3.15. In the year 2004, what is the difference between the Total Labor Force (in %) of South Asia and Total Labor Force (in %) of Burkina Faso?
Ensure brevity in your answer.  -7.05. In the year 2004, what is the difference between the Total Labor Force (in %) in South Asia and Total Labor Force (in %) in Kenya?
Give a very brief answer. 12.75. In the year 2004, what is the difference between the Total Labor Force (in %) of Burkina Faso and Total Labor Force (in %) of Kenya?
Your answer should be compact. 19.8. In the year 2005, what is the difference between the Total Labor Force (in %) of Europe(developing only) and Total Labor Force (in %) of South Asia?
Ensure brevity in your answer.  -15.78. In the year 2005, what is the difference between the Total Labor Force (in %) of Europe(developing only) and Total Labor Force (in %) of Burkina Faso?
Your answer should be compact. -22.7. In the year 2005, what is the difference between the Total Labor Force (in %) in Europe(developing only) and Total Labor Force (in %) in Kenya?
Make the answer very short. -2.3. In the year 2005, what is the difference between the Total Labor Force (in %) of South Asia and Total Labor Force (in %) of Burkina Faso?
Offer a very short reply. -6.92. In the year 2005, what is the difference between the Total Labor Force (in %) in South Asia and Total Labor Force (in %) in Kenya?
Provide a succinct answer. 13.48. In the year 2005, what is the difference between the Total Labor Force (in %) of Burkina Faso and Total Labor Force (in %) of Kenya?
Offer a terse response. 20.4. In the year 2006, what is the difference between the Total Labor Force (in %) in Europe(developing only) and Total Labor Force (in %) in South Asia?
Your response must be concise. -15.38. In the year 2006, what is the difference between the Total Labor Force (in %) in Europe(developing only) and Total Labor Force (in %) in Burkina Faso?
Ensure brevity in your answer.  -22.64. In the year 2006, what is the difference between the Total Labor Force (in %) of Europe(developing only) and Total Labor Force (in %) of Kenya?
Your answer should be compact. -2.54. In the year 2006, what is the difference between the Total Labor Force (in %) of South Asia and Total Labor Force (in %) of Burkina Faso?
Ensure brevity in your answer.  -7.26. In the year 2006, what is the difference between the Total Labor Force (in %) of South Asia and Total Labor Force (in %) of Kenya?
Offer a very short reply. 12.84. In the year 2006, what is the difference between the Total Labor Force (in %) of Burkina Faso and Total Labor Force (in %) of Kenya?
Offer a terse response. 20.1. What is the ratio of the Total Labor Force (in %) in Europe(developing only) in 1999 to that in 2000?
Give a very brief answer. 1.01. What is the ratio of the Total Labor Force (in %) of South Asia in 1999 to that in 2000?
Keep it short and to the point. 1. What is the ratio of the Total Labor Force (in %) in Burkina Faso in 1999 to that in 2000?
Offer a very short reply. 1. What is the ratio of the Total Labor Force (in %) in Kenya in 1999 to that in 2000?
Provide a succinct answer. 1.01. What is the ratio of the Total Labor Force (in %) of Europe(developing only) in 1999 to that in 2001?
Make the answer very short. 1.02. What is the ratio of the Total Labor Force (in %) of South Asia in 1999 to that in 2001?
Offer a very short reply. 1. What is the ratio of the Total Labor Force (in %) in Burkina Faso in 1999 to that in 2001?
Provide a short and direct response. 1. What is the ratio of the Total Labor Force (in %) of Kenya in 1999 to that in 2001?
Offer a very short reply. 1.02. What is the ratio of the Total Labor Force (in %) of Europe(developing only) in 1999 to that in 2002?
Provide a short and direct response. 1.04. What is the ratio of the Total Labor Force (in %) in South Asia in 1999 to that in 2002?
Provide a succinct answer. 1. What is the ratio of the Total Labor Force (in %) of Burkina Faso in 1999 to that in 2002?
Your answer should be very brief. 1. What is the ratio of the Total Labor Force (in %) of Kenya in 1999 to that in 2002?
Offer a terse response. 1.03. What is the ratio of the Total Labor Force (in %) in Europe(developing only) in 1999 to that in 2003?
Provide a succinct answer. 1.04. What is the ratio of the Total Labor Force (in %) of Kenya in 1999 to that in 2003?
Your answer should be very brief. 1.04. What is the ratio of the Total Labor Force (in %) of Europe(developing only) in 1999 to that in 2004?
Offer a terse response. 1.04. What is the ratio of the Total Labor Force (in %) in South Asia in 1999 to that in 2004?
Make the answer very short. 1. What is the ratio of the Total Labor Force (in %) of Kenya in 1999 to that in 2004?
Make the answer very short. 1.05. What is the ratio of the Total Labor Force (in %) of Europe(developing only) in 1999 to that in 2005?
Your answer should be compact. 1.04. What is the ratio of the Total Labor Force (in %) of Kenya in 1999 to that in 2005?
Your answer should be compact. 1.06. What is the ratio of the Total Labor Force (in %) in Europe(developing only) in 1999 to that in 2006?
Provide a succinct answer. 1.04. What is the ratio of the Total Labor Force (in %) in South Asia in 1999 to that in 2006?
Give a very brief answer. 1. What is the ratio of the Total Labor Force (in %) in Kenya in 1999 to that in 2006?
Make the answer very short. 1.05. What is the ratio of the Total Labor Force (in %) of Europe(developing only) in 2000 to that in 2001?
Keep it short and to the point. 1.01. What is the ratio of the Total Labor Force (in %) of Burkina Faso in 2000 to that in 2001?
Keep it short and to the point. 1. What is the ratio of the Total Labor Force (in %) of Kenya in 2000 to that in 2001?
Give a very brief answer. 1.01. What is the ratio of the Total Labor Force (in %) of Europe(developing only) in 2000 to that in 2002?
Keep it short and to the point. 1.02. What is the ratio of the Total Labor Force (in %) of South Asia in 2000 to that in 2002?
Keep it short and to the point. 1. What is the ratio of the Total Labor Force (in %) in Kenya in 2000 to that in 2002?
Keep it short and to the point. 1.02. What is the ratio of the Total Labor Force (in %) of Europe(developing only) in 2000 to that in 2003?
Provide a short and direct response. 1.03. What is the ratio of the Total Labor Force (in %) of South Asia in 2000 to that in 2003?
Provide a short and direct response. 1. What is the ratio of the Total Labor Force (in %) in Kenya in 2000 to that in 2003?
Provide a succinct answer. 1.03. What is the ratio of the Total Labor Force (in %) in Europe(developing only) in 2000 to that in 2004?
Provide a short and direct response. 1.03. What is the ratio of the Total Labor Force (in %) of South Asia in 2000 to that in 2004?
Provide a succinct answer. 1. What is the ratio of the Total Labor Force (in %) of Kenya in 2000 to that in 2004?
Keep it short and to the point. 1.04. What is the ratio of the Total Labor Force (in %) of Europe(developing only) in 2000 to that in 2005?
Your answer should be very brief. 1.03. What is the ratio of the Total Labor Force (in %) in Burkina Faso in 2000 to that in 2005?
Your response must be concise. 1. What is the ratio of the Total Labor Force (in %) in Kenya in 2000 to that in 2005?
Your answer should be compact. 1.05. What is the ratio of the Total Labor Force (in %) of Europe(developing only) in 2000 to that in 2006?
Ensure brevity in your answer.  1.03. What is the ratio of the Total Labor Force (in %) in South Asia in 2000 to that in 2006?
Ensure brevity in your answer.  1. What is the ratio of the Total Labor Force (in %) of Burkina Faso in 2000 to that in 2006?
Your answer should be compact. 1. What is the ratio of the Total Labor Force (in %) of Kenya in 2000 to that in 2006?
Your response must be concise. 1.04. What is the ratio of the Total Labor Force (in %) of Europe(developing only) in 2001 to that in 2002?
Your answer should be very brief. 1.02. What is the ratio of the Total Labor Force (in %) in Kenya in 2001 to that in 2002?
Offer a very short reply. 1.01. What is the ratio of the Total Labor Force (in %) in Europe(developing only) in 2001 to that in 2003?
Ensure brevity in your answer.  1.02. What is the ratio of the Total Labor Force (in %) in South Asia in 2001 to that in 2003?
Offer a terse response. 1. What is the ratio of the Total Labor Force (in %) in Burkina Faso in 2001 to that in 2003?
Provide a short and direct response. 1. What is the ratio of the Total Labor Force (in %) of Kenya in 2001 to that in 2003?
Your answer should be compact. 1.02. What is the ratio of the Total Labor Force (in %) of Europe(developing only) in 2001 to that in 2004?
Your answer should be very brief. 1.02. What is the ratio of the Total Labor Force (in %) of Burkina Faso in 2001 to that in 2004?
Make the answer very short. 1. What is the ratio of the Total Labor Force (in %) of Kenya in 2001 to that in 2004?
Your response must be concise. 1.03. What is the ratio of the Total Labor Force (in %) in Europe(developing only) in 2001 to that in 2005?
Your answer should be compact. 1.02. What is the ratio of the Total Labor Force (in %) in South Asia in 2001 to that in 2005?
Your response must be concise. 1. What is the ratio of the Total Labor Force (in %) in Burkina Faso in 2001 to that in 2005?
Provide a succinct answer. 1. What is the ratio of the Total Labor Force (in %) of Kenya in 2001 to that in 2005?
Give a very brief answer. 1.04. What is the ratio of the Total Labor Force (in %) of Europe(developing only) in 2001 to that in 2006?
Your response must be concise. 1.02. What is the ratio of the Total Labor Force (in %) of South Asia in 2001 to that in 2006?
Provide a succinct answer. 1. What is the ratio of the Total Labor Force (in %) of Burkina Faso in 2001 to that in 2006?
Your answer should be compact. 1. What is the ratio of the Total Labor Force (in %) of Kenya in 2001 to that in 2006?
Give a very brief answer. 1.03. What is the ratio of the Total Labor Force (in %) of Burkina Faso in 2002 to that in 2003?
Offer a very short reply. 1. What is the ratio of the Total Labor Force (in %) of Kenya in 2002 to that in 2003?
Offer a terse response. 1.01. What is the ratio of the Total Labor Force (in %) in Europe(developing only) in 2002 to that in 2004?
Ensure brevity in your answer.  1.01. What is the ratio of the Total Labor Force (in %) in Kenya in 2002 to that in 2004?
Offer a terse response. 1.02. What is the ratio of the Total Labor Force (in %) of Kenya in 2002 to that in 2005?
Ensure brevity in your answer.  1.03. What is the ratio of the Total Labor Force (in %) in Europe(developing only) in 2002 to that in 2006?
Your response must be concise. 1. What is the ratio of the Total Labor Force (in %) of South Asia in 2002 to that in 2006?
Offer a very short reply. 1. What is the ratio of the Total Labor Force (in %) in Burkina Faso in 2002 to that in 2006?
Provide a short and direct response. 1. What is the ratio of the Total Labor Force (in %) in Kenya in 2002 to that in 2006?
Provide a succinct answer. 1.02. What is the ratio of the Total Labor Force (in %) in Europe(developing only) in 2003 to that in 2004?
Provide a succinct answer. 1. What is the ratio of the Total Labor Force (in %) of South Asia in 2003 to that in 2004?
Make the answer very short. 1. What is the ratio of the Total Labor Force (in %) in Kenya in 2003 to that in 2004?
Make the answer very short. 1.01. What is the ratio of the Total Labor Force (in %) in Europe(developing only) in 2003 to that in 2005?
Your response must be concise. 0.99. What is the ratio of the Total Labor Force (in %) of South Asia in 2003 to that in 2005?
Offer a terse response. 1. What is the ratio of the Total Labor Force (in %) in Burkina Faso in 2003 to that in 2005?
Your answer should be compact. 1. What is the ratio of the Total Labor Force (in %) of Kenya in 2003 to that in 2005?
Make the answer very short. 1.02. What is the ratio of the Total Labor Force (in %) of Burkina Faso in 2003 to that in 2006?
Your answer should be compact. 1. What is the ratio of the Total Labor Force (in %) of Kenya in 2003 to that in 2006?
Provide a short and direct response. 1.01. What is the ratio of the Total Labor Force (in %) of South Asia in 2004 to that in 2005?
Your response must be concise. 1. What is the ratio of the Total Labor Force (in %) in Burkina Faso in 2004 to that in 2005?
Your answer should be compact. 1. What is the ratio of the Total Labor Force (in %) in Kenya in 2004 to that in 2005?
Keep it short and to the point. 1.01. What is the ratio of the Total Labor Force (in %) of Europe(developing only) in 2004 to that in 2006?
Your response must be concise. 1. What is the ratio of the Total Labor Force (in %) of Burkina Faso in 2004 to that in 2006?
Provide a short and direct response. 1. What is the ratio of the Total Labor Force (in %) of Kenya in 2004 to that in 2006?
Offer a very short reply. 1. What is the ratio of the Total Labor Force (in %) in South Asia in 2005 to that in 2006?
Offer a very short reply. 1. What is the ratio of the Total Labor Force (in %) of Burkina Faso in 2005 to that in 2006?
Your answer should be very brief. 1. What is the ratio of the Total Labor Force (in %) of Kenya in 2005 to that in 2006?
Provide a short and direct response. 1. What is the difference between the highest and the second highest Total Labor Force (in %) of Europe(developing only)?
Offer a very short reply. 0.9. What is the difference between the highest and the second highest Total Labor Force (in %) in South Asia?
Provide a short and direct response. 0.11. What is the difference between the highest and the second highest Total Labor Force (in %) of Kenya?
Keep it short and to the point. 0.7. What is the difference between the highest and the lowest Total Labor Force (in %) in Europe(developing only)?
Provide a short and direct response. 3.03. What is the difference between the highest and the lowest Total Labor Force (in %) of South Asia?
Provide a succinct answer. 0.34. What is the difference between the highest and the lowest Total Labor Force (in %) of Burkina Faso?
Offer a terse response. 0.1. 